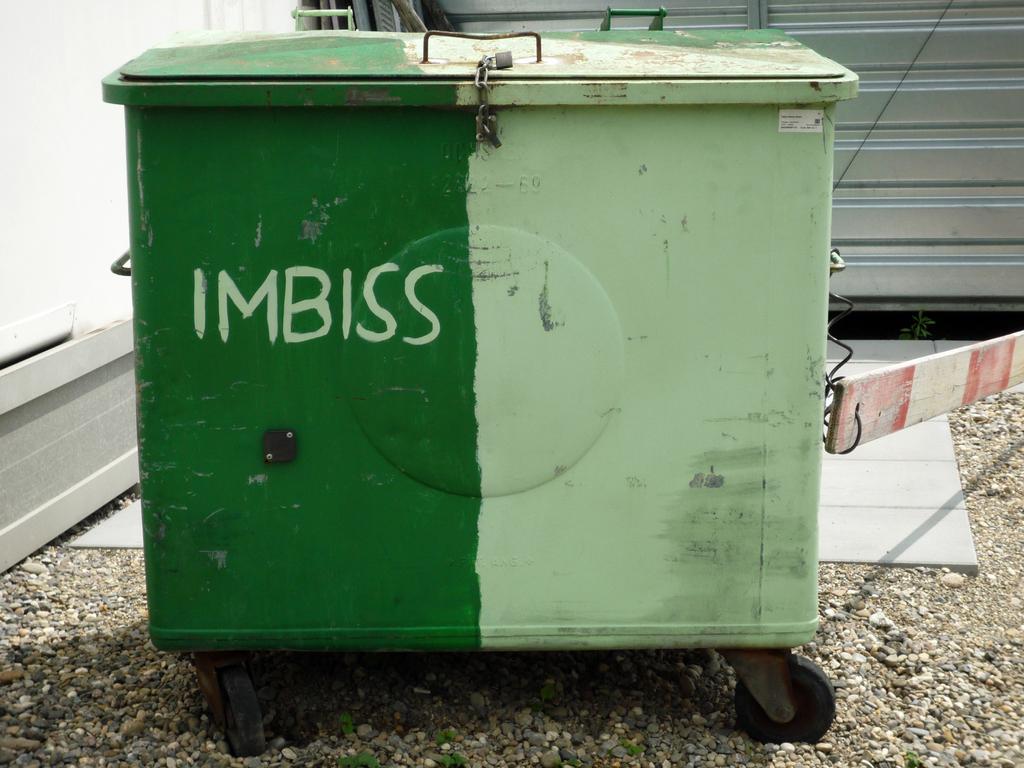Could you give a brief overview of what you see in this image? In this picture there is a box and there is a text on the box and it has wheels. At the back there is a railing. At the bottom there are stones. 